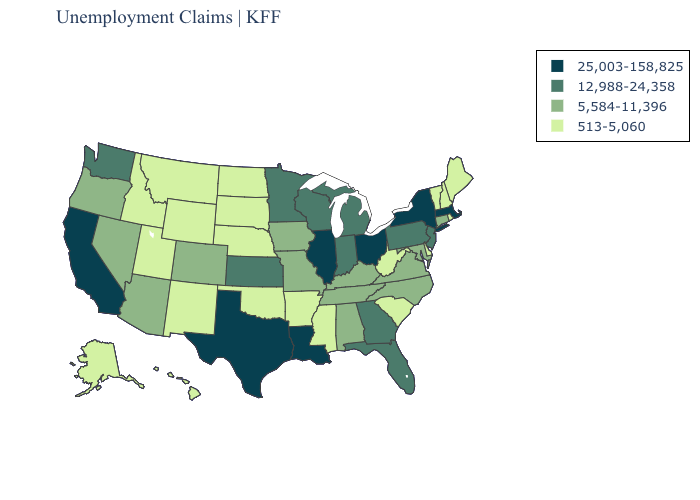Which states have the lowest value in the USA?
Concise answer only. Alaska, Arkansas, Delaware, Hawaii, Idaho, Maine, Mississippi, Montana, Nebraska, New Hampshire, New Mexico, North Dakota, Oklahoma, Rhode Island, South Carolina, South Dakota, Utah, Vermont, West Virginia, Wyoming. Among the states that border Iowa , does South Dakota have the lowest value?
Short answer required. Yes. Does North Dakota have the highest value in the MidWest?
Be succinct. No. What is the lowest value in the Northeast?
Short answer required. 513-5,060. Does Pennsylvania have the same value as Georgia?
Answer briefly. Yes. Name the states that have a value in the range 25,003-158,825?
Give a very brief answer. California, Illinois, Louisiana, Massachusetts, New York, Ohio, Texas. Does South Dakota have the lowest value in the MidWest?
Concise answer only. Yes. Does New Mexico have the highest value in the USA?
Keep it brief. No. Name the states that have a value in the range 513-5,060?
Quick response, please. Alaska, Arkansas, Delaware, Hawaii, Idaho, Maine, Mississippi, Montana, Nebraska, New Hampshire, New Mexico, North Dakota, Oklahoma, Rhode Island, South Carolina, South Dakota, Utah, Vermont, West Virginia, Wyoming. Among the states that border Indiana , does Michigan have the lowest value?
Short answer required. No. Name the states that have a value in the range 12,988-24,358?
Short answer required. Florida, Georgia, Indiana, Kansas, Michigan, Minnesota, New Jersey, Pennsylvania, Washington, Wisconsin. Among the states that border Alabama , which have the lowest value?
Quick response, please. Mississippi. Name the states that have a value in the range 12,988-24,358?
Answer briefly. Florida, Georgia, Indiana, Kansas, Michigan, Minnesota, New Jersey, Pennsylvania, Washington, Wisconsin. Does Maine have the highest value in the Northeast?
Write a very short answer. No. Which states have the lowest value in the USA?
Answer briefly. Alaska, Arkansas, Delaware, Hawaii, Idaho, Maine, Mississippi, Montana, Nebraska, New Hampshire, New Mexico, North Dakota, Oklahoma, Rhode Island, South Carolina, South Dakota, Utah, Vermont, West Virginia, Wyoming. 